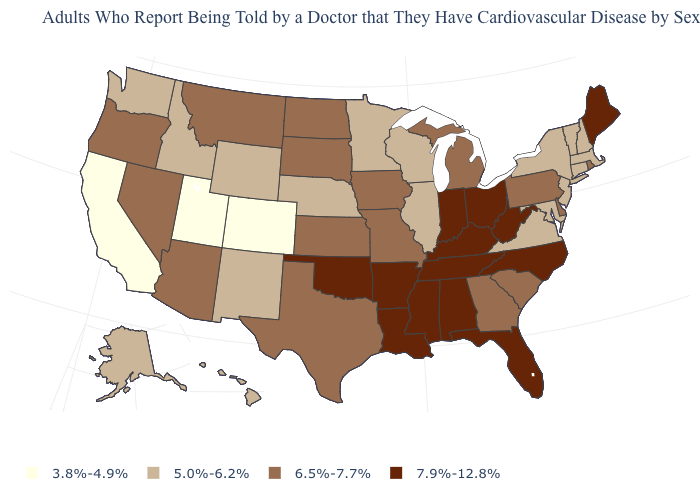Does Illinois have the lowest value in the MidWest?
Quick response, please. Yes. What is the value of Massachusetts?
Keep it brief. 5.0%-6.2%. What is the value of Idaho?
Concise answer only. 5.0%-6.2%. Does Connecticut have a lower value than Kansas?
Quick response, please. Yes. Is the legend a continuous bar?
Quick response, please. No. What is the value of Louisiana?
Write a very short answer. 7.9%-12.8%. Does Alabama have the highest value in the South?
Answer briefly. Yes. Which states have the lowest value in the USA?
Keep it brief. California, Colorado, Utah. Is the legend a continuous bar?
Give a very brief answer. No. Which states have the lowest value in the Northeast?
Quick response, please. Connecticut, Massachusetts, New Hampshire, New Jersey, New York, Vermont. Which states have the lowest value in the South?
Be succinct. Maryland, Virginia. What is the highest value in the Northeast ?
Give a very brief answer. 7.9%-12.8%. Does Nebraska have the lowest value in the MidWest?
Short answer required. Yes. Does Arkansas have the highest value in the USA?
Concise answer only. Yes. Does the map have missing data?
Be succinct. No. 